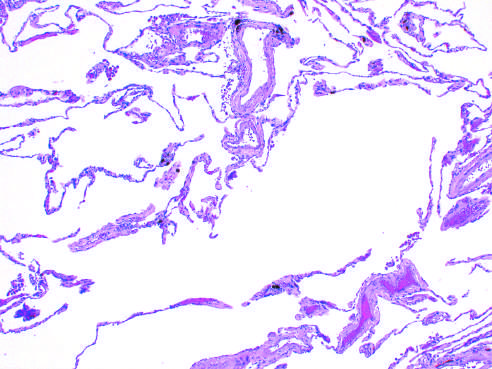s there marked enlargement of the air spaces, with destruction of alveolar septa but without fibrosis?
Answer the question using a single word or phrase. Yes 